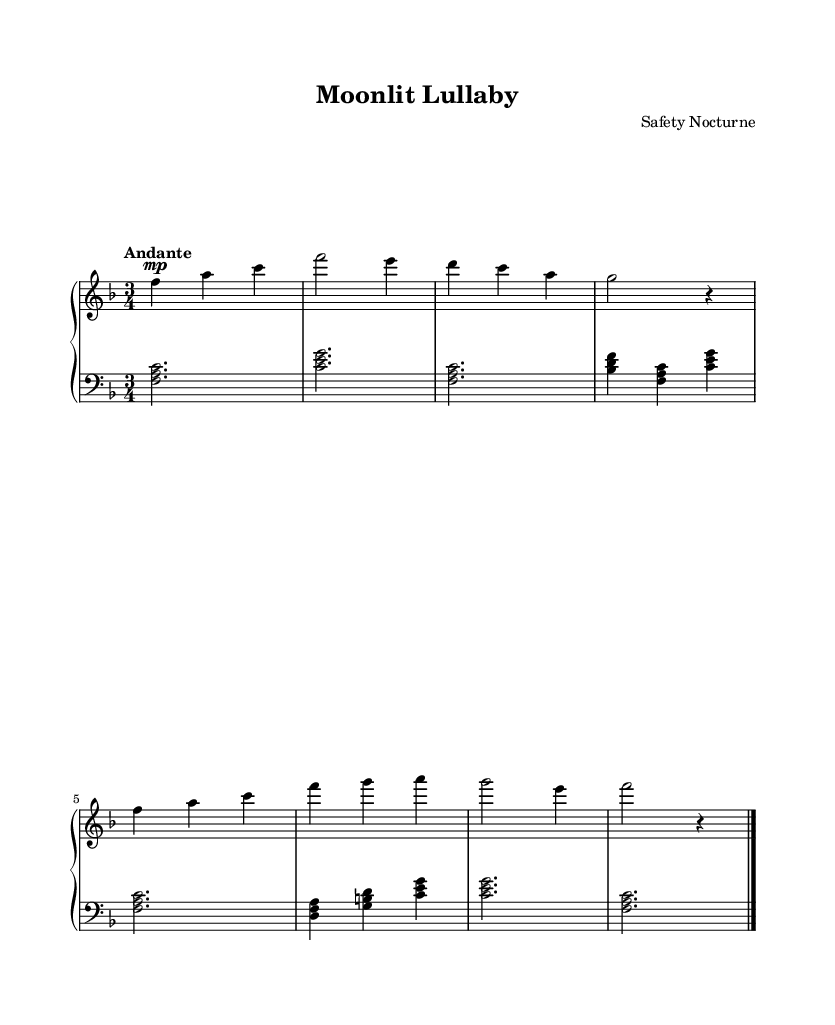What is the key signature of this music? The key signature is F major, which has one flat (B flat). This is indicated at the beginning of the staff.
Answer: F major What is the time signature of this piece? The time signature is 3/4, which is noted at the beginning of the staff as a fraction. This signifies three beats per measure with a quarter note receiving one beat.
Answer: 3/4 What is the tempo marking for this piece? The tempo marking is "Andante," suggesting a moderately slow pace, typically ranging from 76 to 108 beats per minute. It appears at the beginning of the upper staff.
Answer: Andante What is the dynamic marking for the first measure? The dynamic marking for the first measure is "mp," which stands for mezzo-piano, indicating a moderately soft volume. This marking appears before the first note in the upper staff.
Answer: mezzo-piano How many measures are in the piece? There are eight measures in the shown score as indicated by the presence of measure bars and counting through the score.
Answer: 8 What type of piece is "Moonlit Lullaby"? "Moonlit Lullaby" can be classified as a romantic classical piano piece, characterized by its lyrical melodies and expressive dynamics. This is inferred from its title and the style of the music generated in the sheet.
Answer: Romantic classical piano 